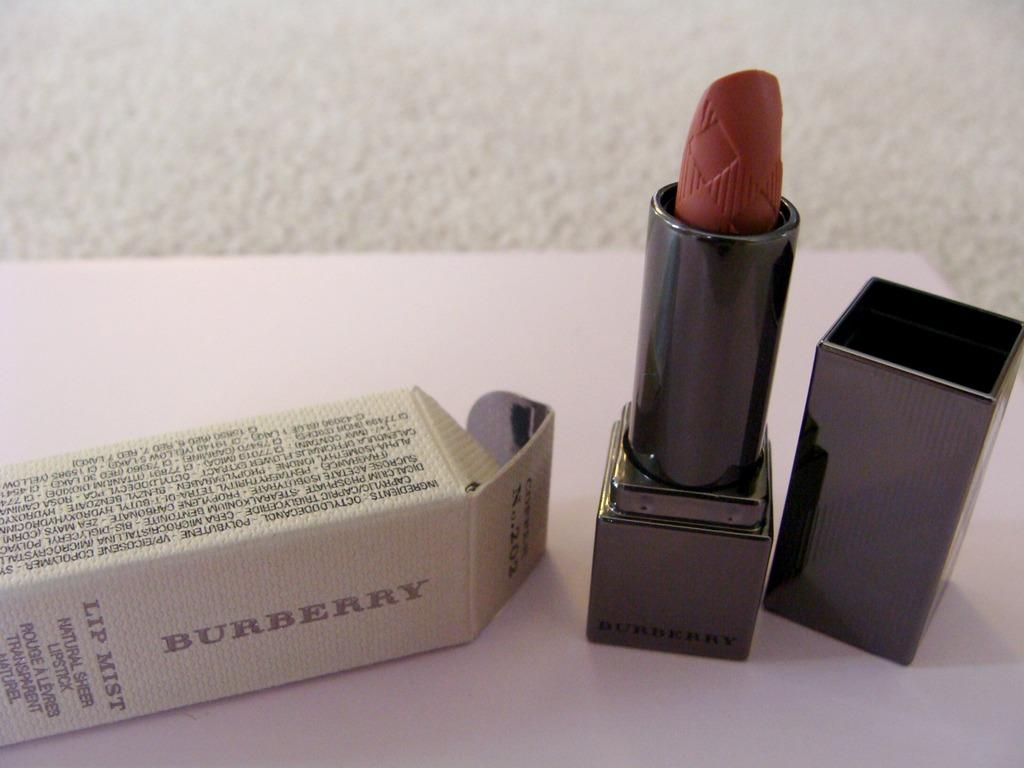Provide a one-sentence caption for the provided image. Unused Burberry Lip Mist lip stick positioned next to it's original packaging. 